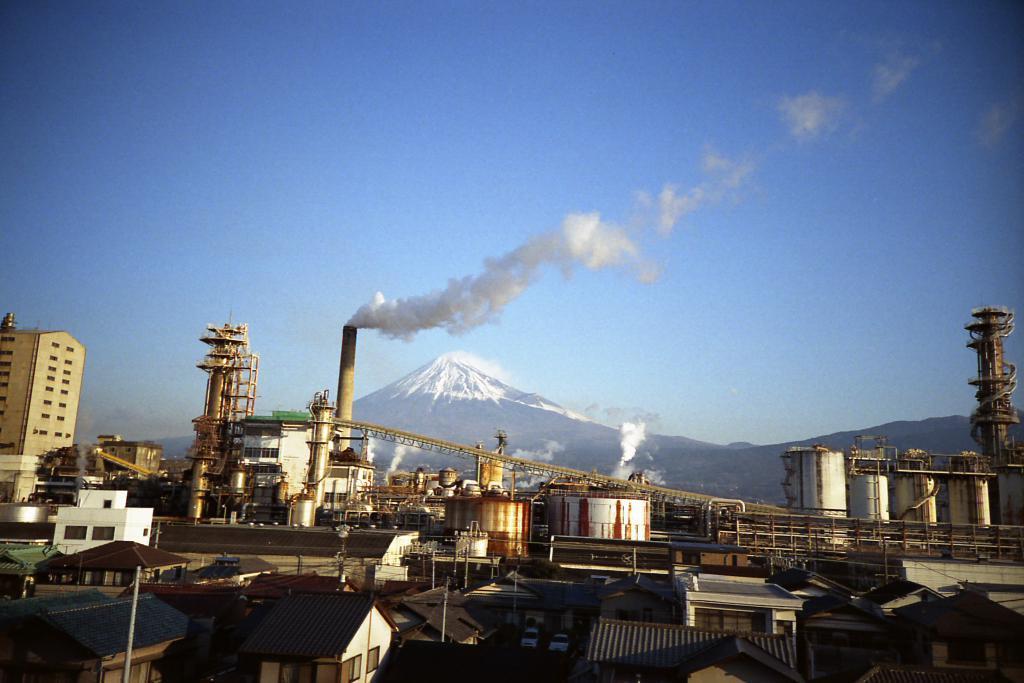Please provide a concise description of this image. In this image, I can see the buildings and a factory. I can see a snowy mountain, which is behind the factory. In the background, there is the sky. 